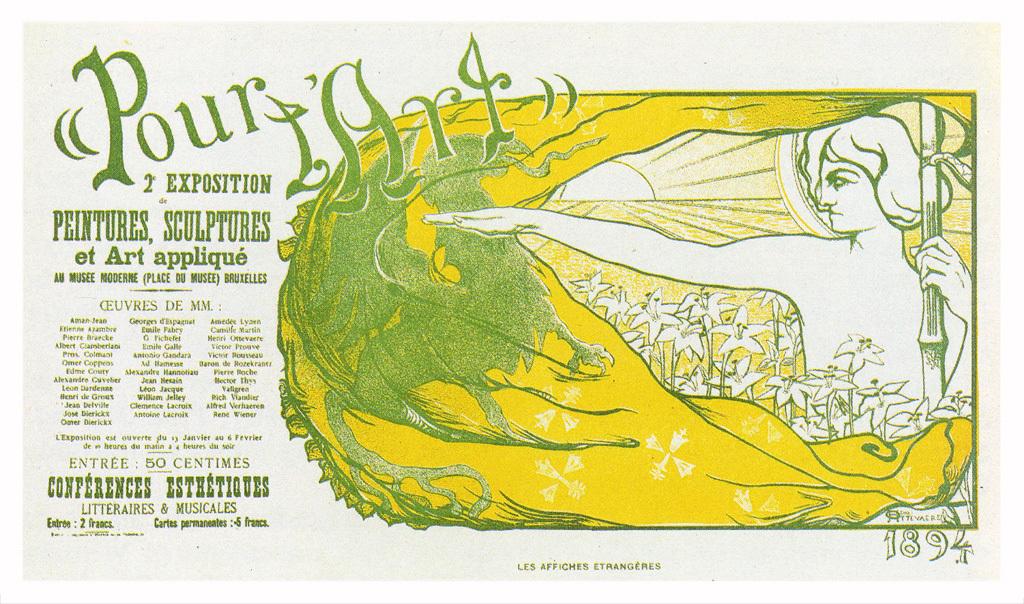What year did the pour l'art conference take place?
Offer a very short reply. 1894. What is the title of this event?
Provide a succinct answer. Pour l art. 